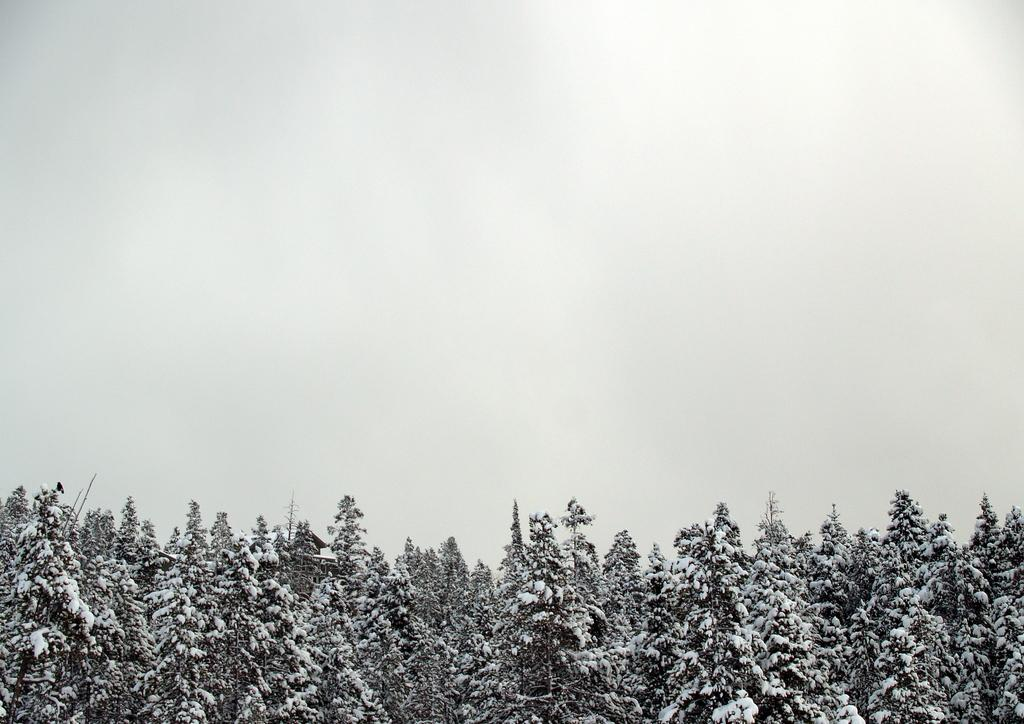What type of vegetation is present at the bottom of the image? There are green trees at the bottom of the image. What is the condition of the sky in the image? The sky is foggy at the top of the image. What type of liquid can be seen flowing through the trees in the image? There is no liquid flowing through the trees in the image; it only features green trees and a foggy sky. How many seats are visible in the image? There are no seats present in the image. 